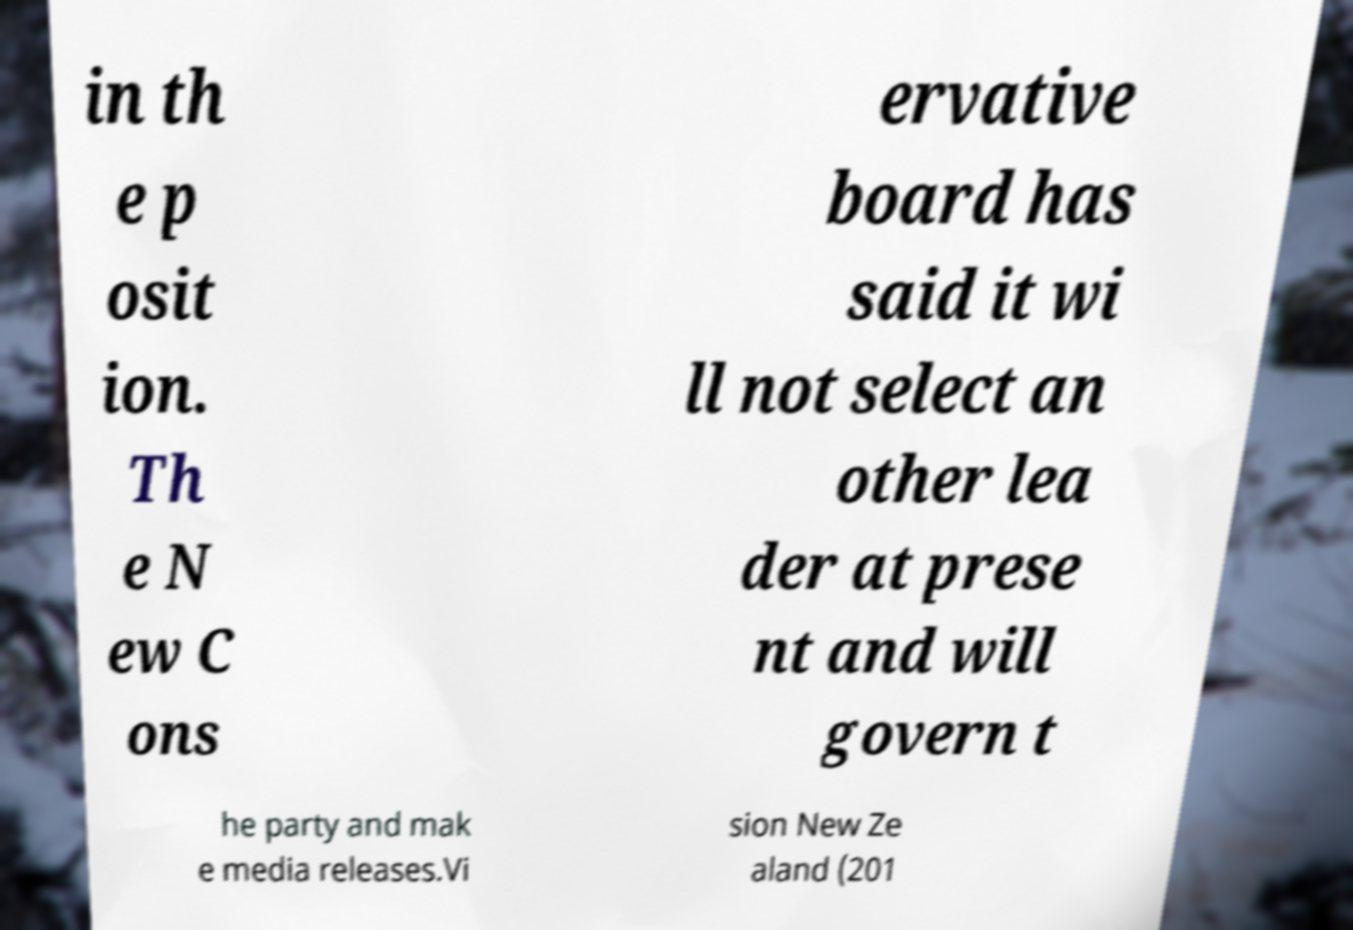I need the written content from this picture converted into text. Can you do that? in th e p osit ion. Th e N ew C ons ervative board has said it wi ll not select an other lea der at prese nt and will govern t he party and mak e media releases.Vi sion New Ze aland (201 